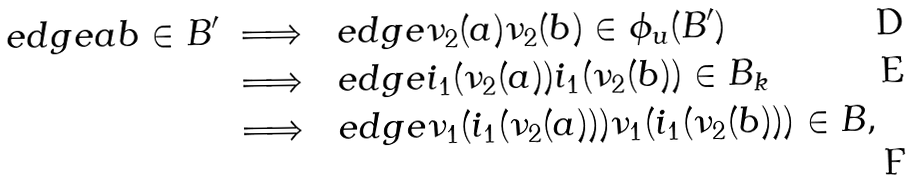<formula> <loc_0><loc_0><loc_500><loc_500>\ e d g e { a b } \in B ^ { \prime } \ & \Longrightarrow \ \ e d g e { \nu _ { 2 } ( a ) \nu _ { 2 } ( b ) } \in \phi _ { u } ( B ^ { \prime } ) \\ & \Longrightarrow \ \ e d g e { i _ { 1 } ( \nu _ { 2 } ( a ) ) i _ { 1 } ( \nu _ { 2 } ( b ) ) } \in B _ { k } \\ & \Longrightarrow \ \ e d g e { \nu _ { 1 } ( i _ { 1 } ( \nu _ { 2 } ( a ) ) ) \nu _ { 1 } ( i _ { 1 } ( \nu _ { 2 } ( b ) ) ) } \in B ,</formula> 